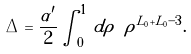<formula> <loc_0><loc_0><loc_500><loc_500>\Delta = \frac { \alpha ^ { \prime } } { 2 } \int _ { 0 } ^ { 1 } \, d \rho \ \rho ^ { L _ { 0 } + \tilde { L } _ { 0 } - 3 } .</formula> 